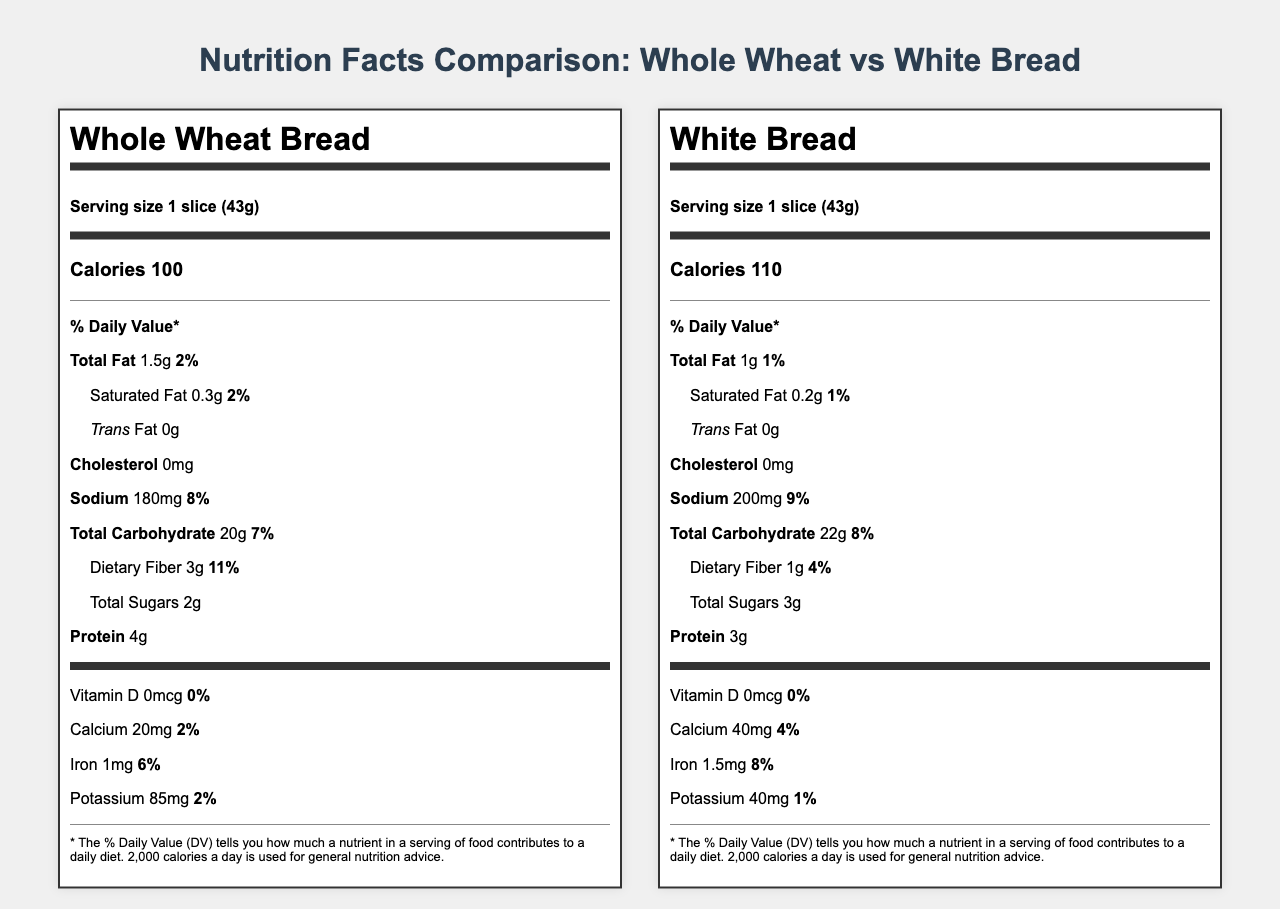what is the serving size for whole wheat bread? The serving size for whole wheat bread as listed in the document is "1 slice (43g)".
Answer: 1 slice (43g) how many calories are in a slice of white bread? The document states that white bread has 110 calories per slice.
Answer: 110 which bread has more dietary fiber per serving? The document lists that whole wheat bread contains 3g of dietary fiber per serving, whereas white bread contains only 1g per serving.
Answer: Whole wheat bread what is the % Daily Value of sodium in a slice of whole wheat bread? According to the document, the % Daily Value of sodium in whole wheat bread is 8%.
Answer: 8% what is the amount of iron in a serving of white bread? As indicated in the document, white bread has 1.5mg of iron per serving.
Answer: 1.5mg which bread has more total carbohydrates per serving? A. Whole wheat bread B. White bread White bread contains 22g of total carbohydrates per serving, while whole wheat bread contains 20g.
Answer: B which bread has a higher calorie count? I. Whole wheat bread II. White bread III. Both have the same calorie count White bread has 110 calories per serving, whereas whole wheat bread has 100 calories.
Answer: II is there any trans fat in either type of bread? The document shows that both whole wheat bread and white bread have 0g of trans fat.
Answer: No summarize the main differences between whole wheat bread and white bread as shown in the nutrition facts labels. The summary points out the main differences found by comparing the nutritional information listed on the document for both types of bread.
Answer: Whole wheat bread generally has lower calories, more dietary fiber, and less sugar compared to white bread. White bread has slightly more iron and calcium and also has a higher sodium and total carbohydrate content. what are the potassium values for both breads? The document states that whole wheat bread contains 85mg of potassium, while white bread contains 40mg of potassium per serving.
Answer: Whole wheat bread: 85mg, White bread: 40mg which bread has a higher % Daily Value for total fat? A. Whole wheat bread B. White bread C. Both have the same Whole wheat bread has a total fat % Daily Value of 2%, while white bread has a total fat % Daily Value of 1%.
Answer: A which type of bread contains more sugars per serving? The document shows that white bread contains 3g of total sugars per serving, while whole wheat bread contains 2g.
Answer: White bread can we determine the glycemic index for both bread types from this document? The document does not provide glycemic index values, so we cannot determine it from the visual information provided.
Answer: Not enough information 